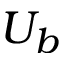Convert formula to latex. <formula><loc_0><loc_0><loc_500><loc_500>U _ { b }</formula> 